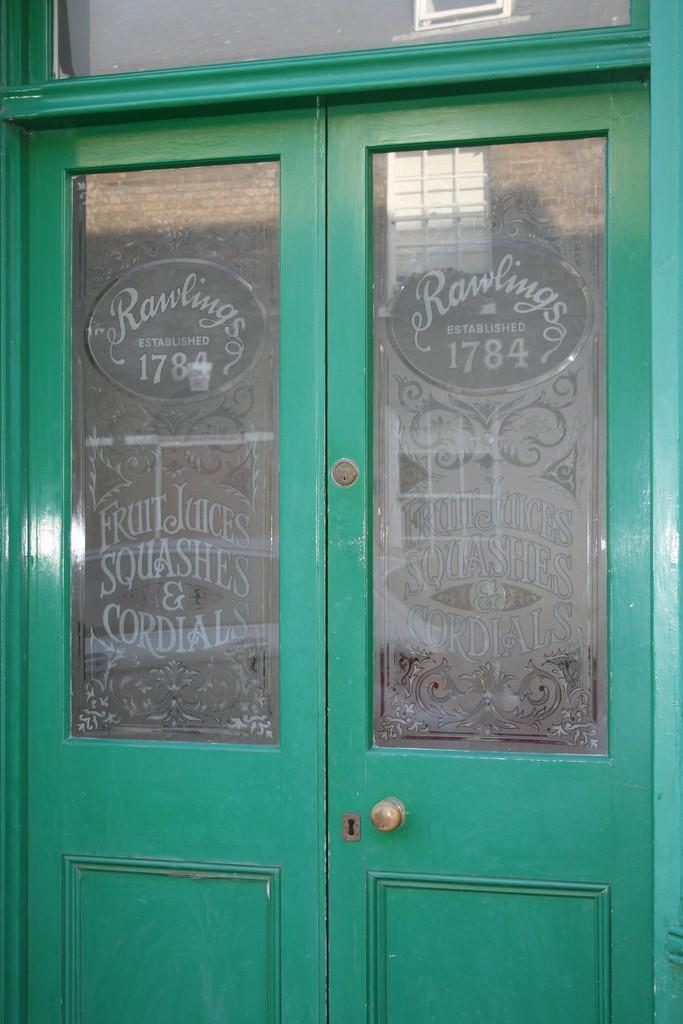What color is the door in the image? The door in the image is green. What feature does the door have? The door has some glass. What can be seen on the glass? There is text written on the glass. How many horses are visible through the glass on the door? There are no horses visible through the glass on the door; the text written on the glass is the focus of the image. 